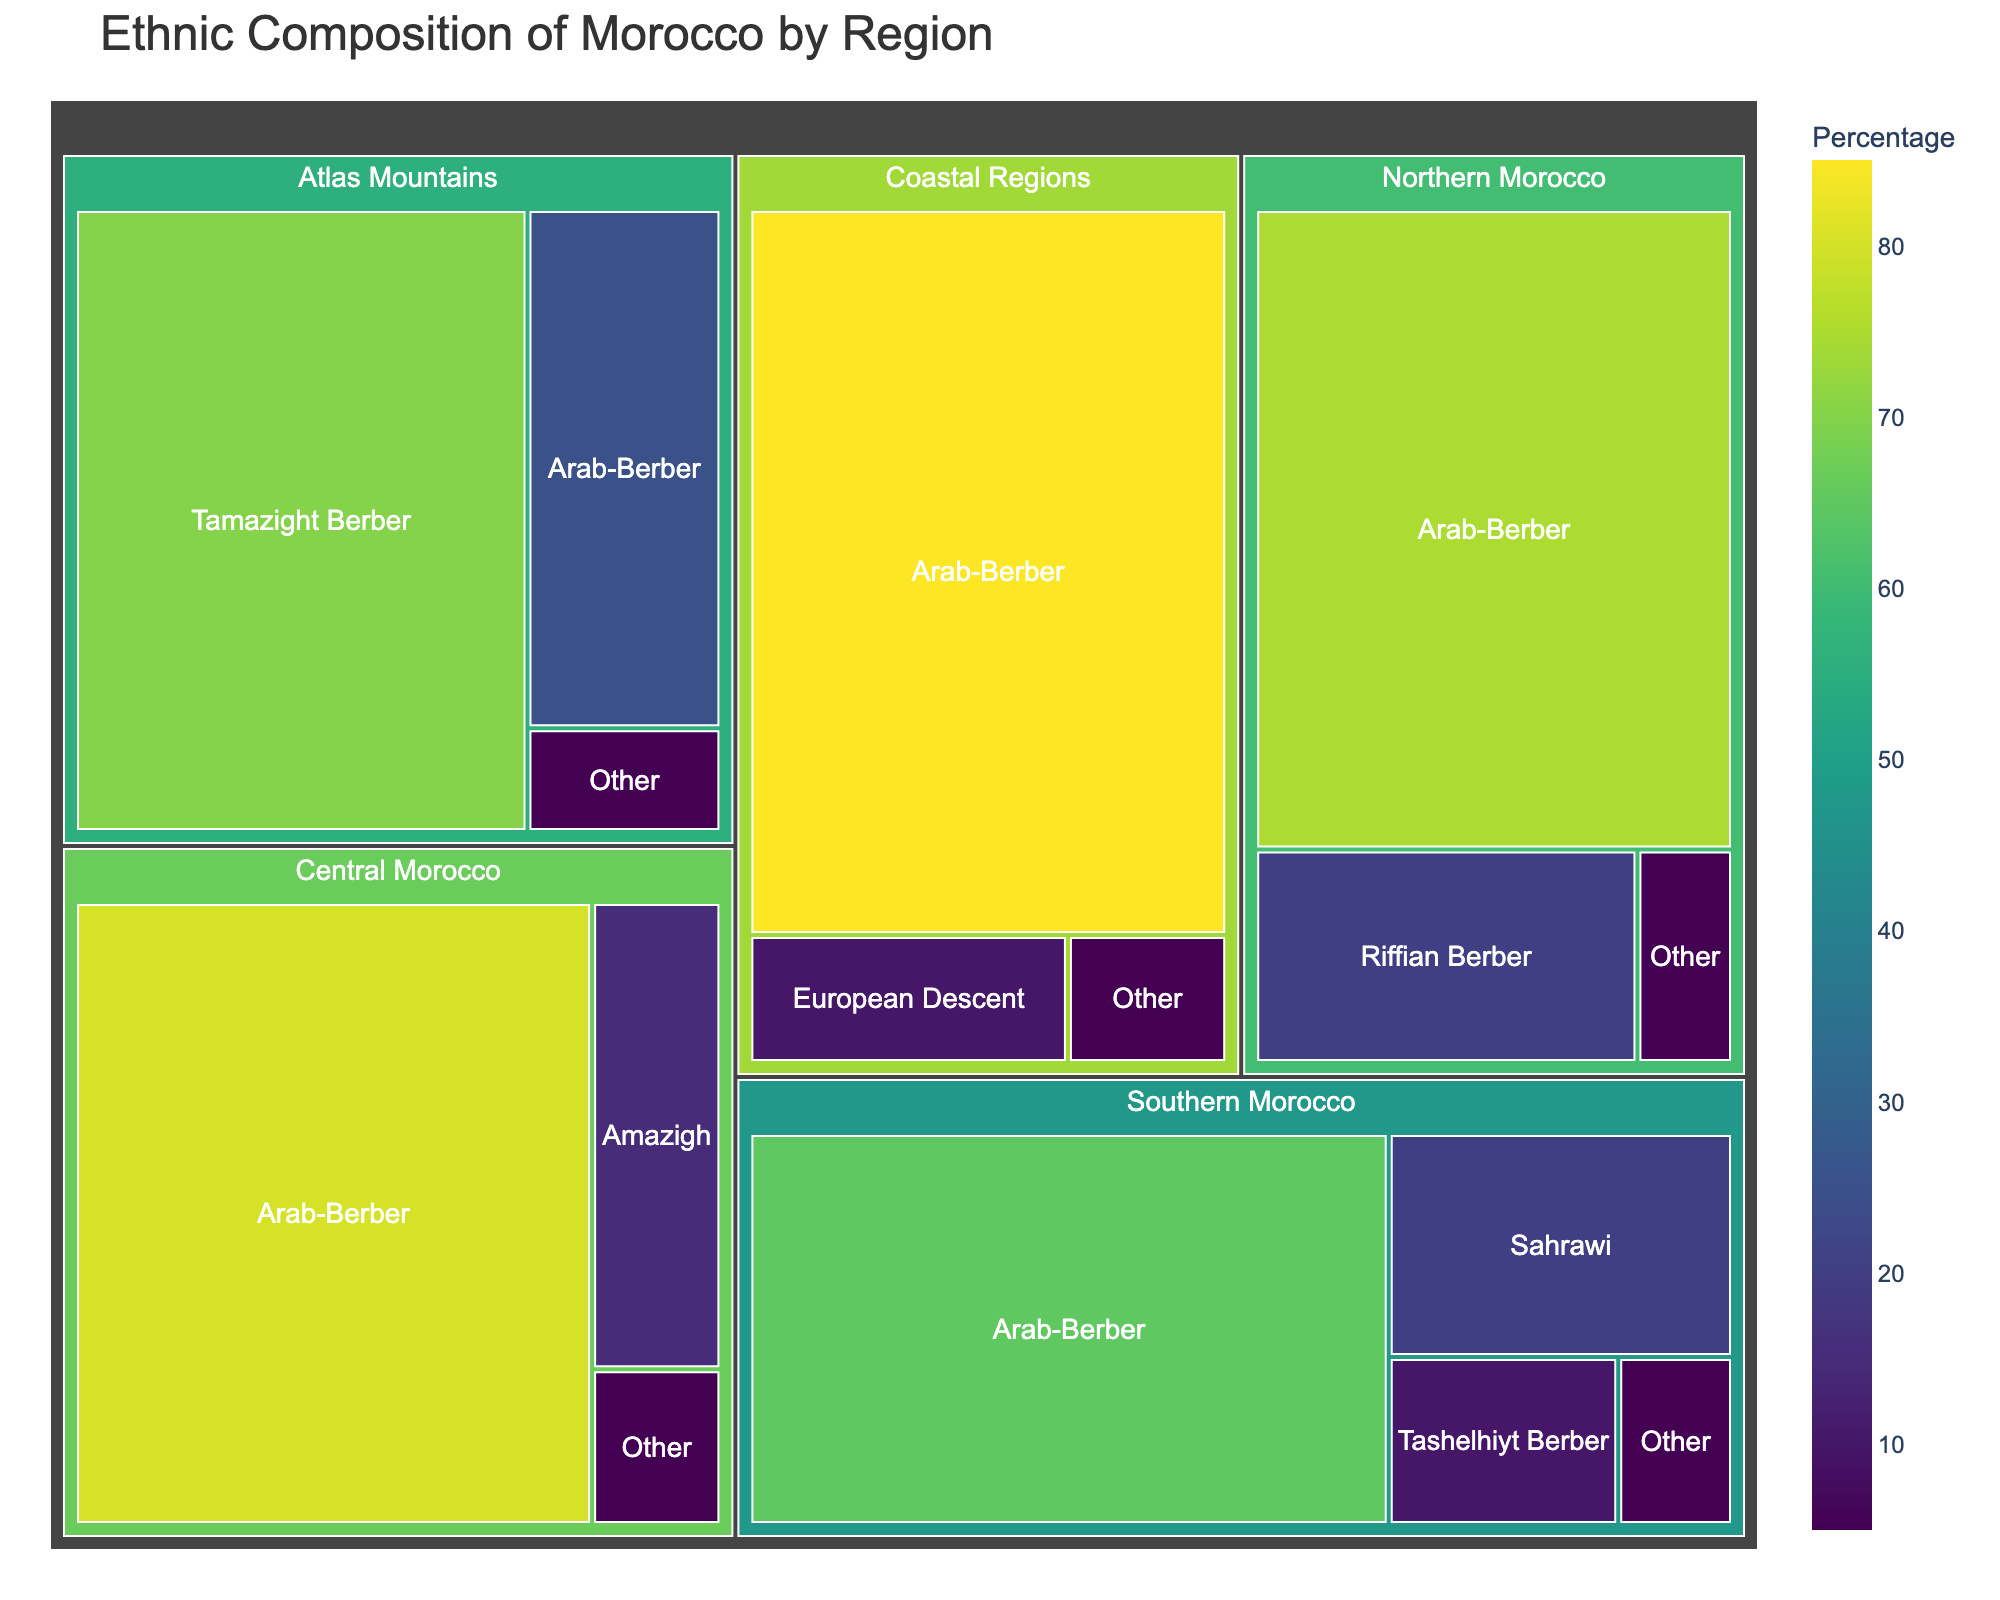What is the title of the figure? The title is typically located at the top of the figure in a larger font size, providing a clear summary of what the figure represents. In this case, the title reads "Ethnic Composition of Morocco by Region".
Answer: Ethnic Composition of Morocco by Region How many ethnic groups are listed for Southern Morocco? To determine the number of ethnic groups in Southern Morocco, we count the unique groups labeled under the Southern Morocco region. The groups are Arab-Berber, Sahrawi, Tashelhiyt Berber, and Other.
Answer: 4 Which region has the highest percentage of Arab-Berbers? Compare the Arab-Berber percentages listed for each region: Northern Morocco (75%), Central Morocco (80%), Southern Morocco (65%), Atlas Mountains (25%), and Coastal Regions (85%). The Coastal Regions has the highest percentage.
Answer: Coastal Regions What is the total percentage of 'Other' ethnicities across all regions? To calculate the total percentage, we sum the 'Other' percentages for each region: Northern Morocco (5%), Central Morocco (5%), Southern Morocco (5%), Atlas Mountains (5%), and Coastal Regions (5%). The total is 5 + 5 + 5 + 5 + 5 = 25%.
Answer: 25% Which region has the least percentage of Tamazight Berber? By examining the figure, we identify the regions with Tamazight Berber: Atlas Mountains (70%). Since Tamazight Berber only appears in the Atlas Mountains, this region has the least and the most percentage of this ethnic group.
Answer: Atlas Mountains How does the percentage of Riffian Berber in Northern Morocco compare to the Sahrawi in Southern Morocco? Northern Morocco has a 20% Riffian Berber population, while Southern Morocco has a 20% Sahrawi population. Comparing these values, both percentages are equal.
Answer: Equal Which ethnic group is the most predominant in Central Morocco and by what percentage? By inspecting the provided data for Central Morocco, Arab-Berber is the most predominant ethnic group at 80%.
Answer: Arab-Berber, 80% What is the combined percentage of Berber-related ethnic groups in the Atlas Mountains? Sum the percentages of all Berber-related groups in the Atlas Mountains: Tamazight Berber (70%) and Arab-Berber (25%). The total is 70 + 25 = 95%.
Answer: 95% Which region shows the least ethnic diversity, based on the given data? Ethnic diversity can be inferred by the number and distribution of different ethnic groups. The Coastal Regions has three ethnic groups and the highest percentage for a single group (Arab-Berber at 85%).
Answer: Coastal Regions 